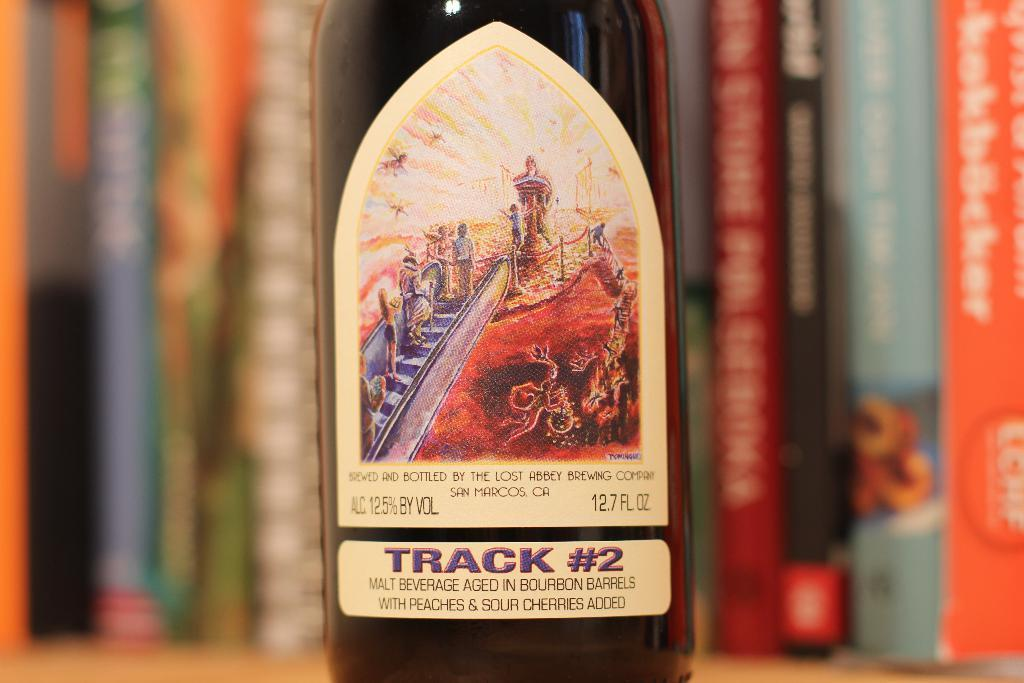What object can be seen in the image? There is a bottle in the image. What color is the background of the bottle? The background of the bottle is blue. How many men are walking down the hall in the image? There are no men or hall present in the image; it only features a bottle with a blue background. What type of boot is visible on the floor in the image? There is no boot present in the image; it only features a bottle with a blue background. 